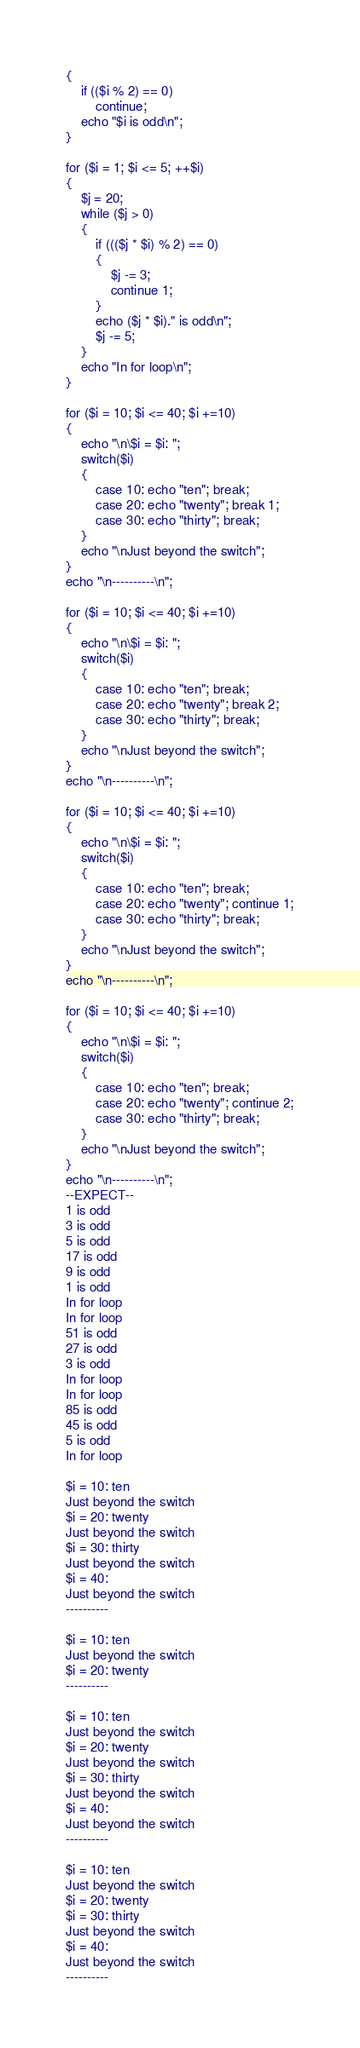Convert code to text. <code><loc_0><loc_0><loc_500><loc_500><_PHP_>{
	if (($i % 2) == 0)
		continue;
	echo "$i is odd\n";
}

for ($i = 1; $i <= 5; ++$i)
{
	$j = 20;
	while ($j > 0)
	{
		if ((($j * $i) % 2) == 0)
		{
			$j -= 3;
			continue 1;
		}
		echo ($j * $i)." is odd\n";
		$j -= 5;
	}
	echo "In for loop\n";
}

for ($i = 10; $i <= 40; $i +=10)
{
	echo "\n\$i = $i: ";
	switch($i)
	{
		case 10: echo "ten"; break;
		case 20: echo "twenty"; break 1;
		case 30: echo "thirty"; break;
	}
	echo "\nJust beyond the switch";
}
echo "\n----------\n";

for ($i = 10; $i <= 40; $i +=10)
{
	echo "\n\$i = $i: ";
	switch($i)
	{
		case 10: echo "ten"; break;
		case 20: echo "twenty"; break 2;
		case 30: echo "thirty"; break;
	}
	echo "\nJust beyond the switch";
}
echo "\n----------\n";

for ($i = 10; $i <= 40; $i +=10)
{
	echo "\n\$i = $i: ";
	switch($i)
	{
		case 10: echo "ten"; break;
		case 20: echo "twenty"; continue 1;
		case 30: echo "thirty"; break;
	}
	echo "\nJust beyond the switch";
}
echo "\n----------\n";

for ($i = 10; $i <= 40; $i +=10)
{
	echo "\n\$i = $i: ";
	switch($i)
	{
		case 10: echo "ten"; break;
		case 20: echo "twenty"; continue 2;
		case 30: echo "thirty"; break;
	}
	echo "\nJust beyond the switch";
}
echo "\n----------\n";
--EXPECT--
1 is odd
3 is odd
5 is odd
17 is odd
9 is odd
1 is odd
In for loop
In for loop
51 is odd
27 is odd
3 is odd
In for loop
In for loop
85 is odd
45 is odd
5 is odd
In for loop

$i = 10: ten
Just beyond the switch
$i = 20: twenty
Just beyond the switch
$i = 30: thirty
Just beyond the switch
$i = 40: 
Just beyond the switch
----------

$i = 10: ten
Just beyond the switch
$i = 20: twenty
----------

$i = 10: ten
Just beyond the switch
$i = 20: twenty
Just beyond the switch
$i = 30: thirty
Just beyond the switch
$i = 40: 
Just beyond the switch
----------

$i = 10: ten
Just beyond the switch
$i = 20: twenty
$i = 30: thirty
Just beyond the switch
$i = 40: 
Just beyond the switch
----------</code> 